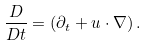<formula> <loc_0><loc_0><loc_500><loc_500>\frac { D } { D t } = \left ( \partial _ { t } + u \cdot \nabla \right ) .</formula> 